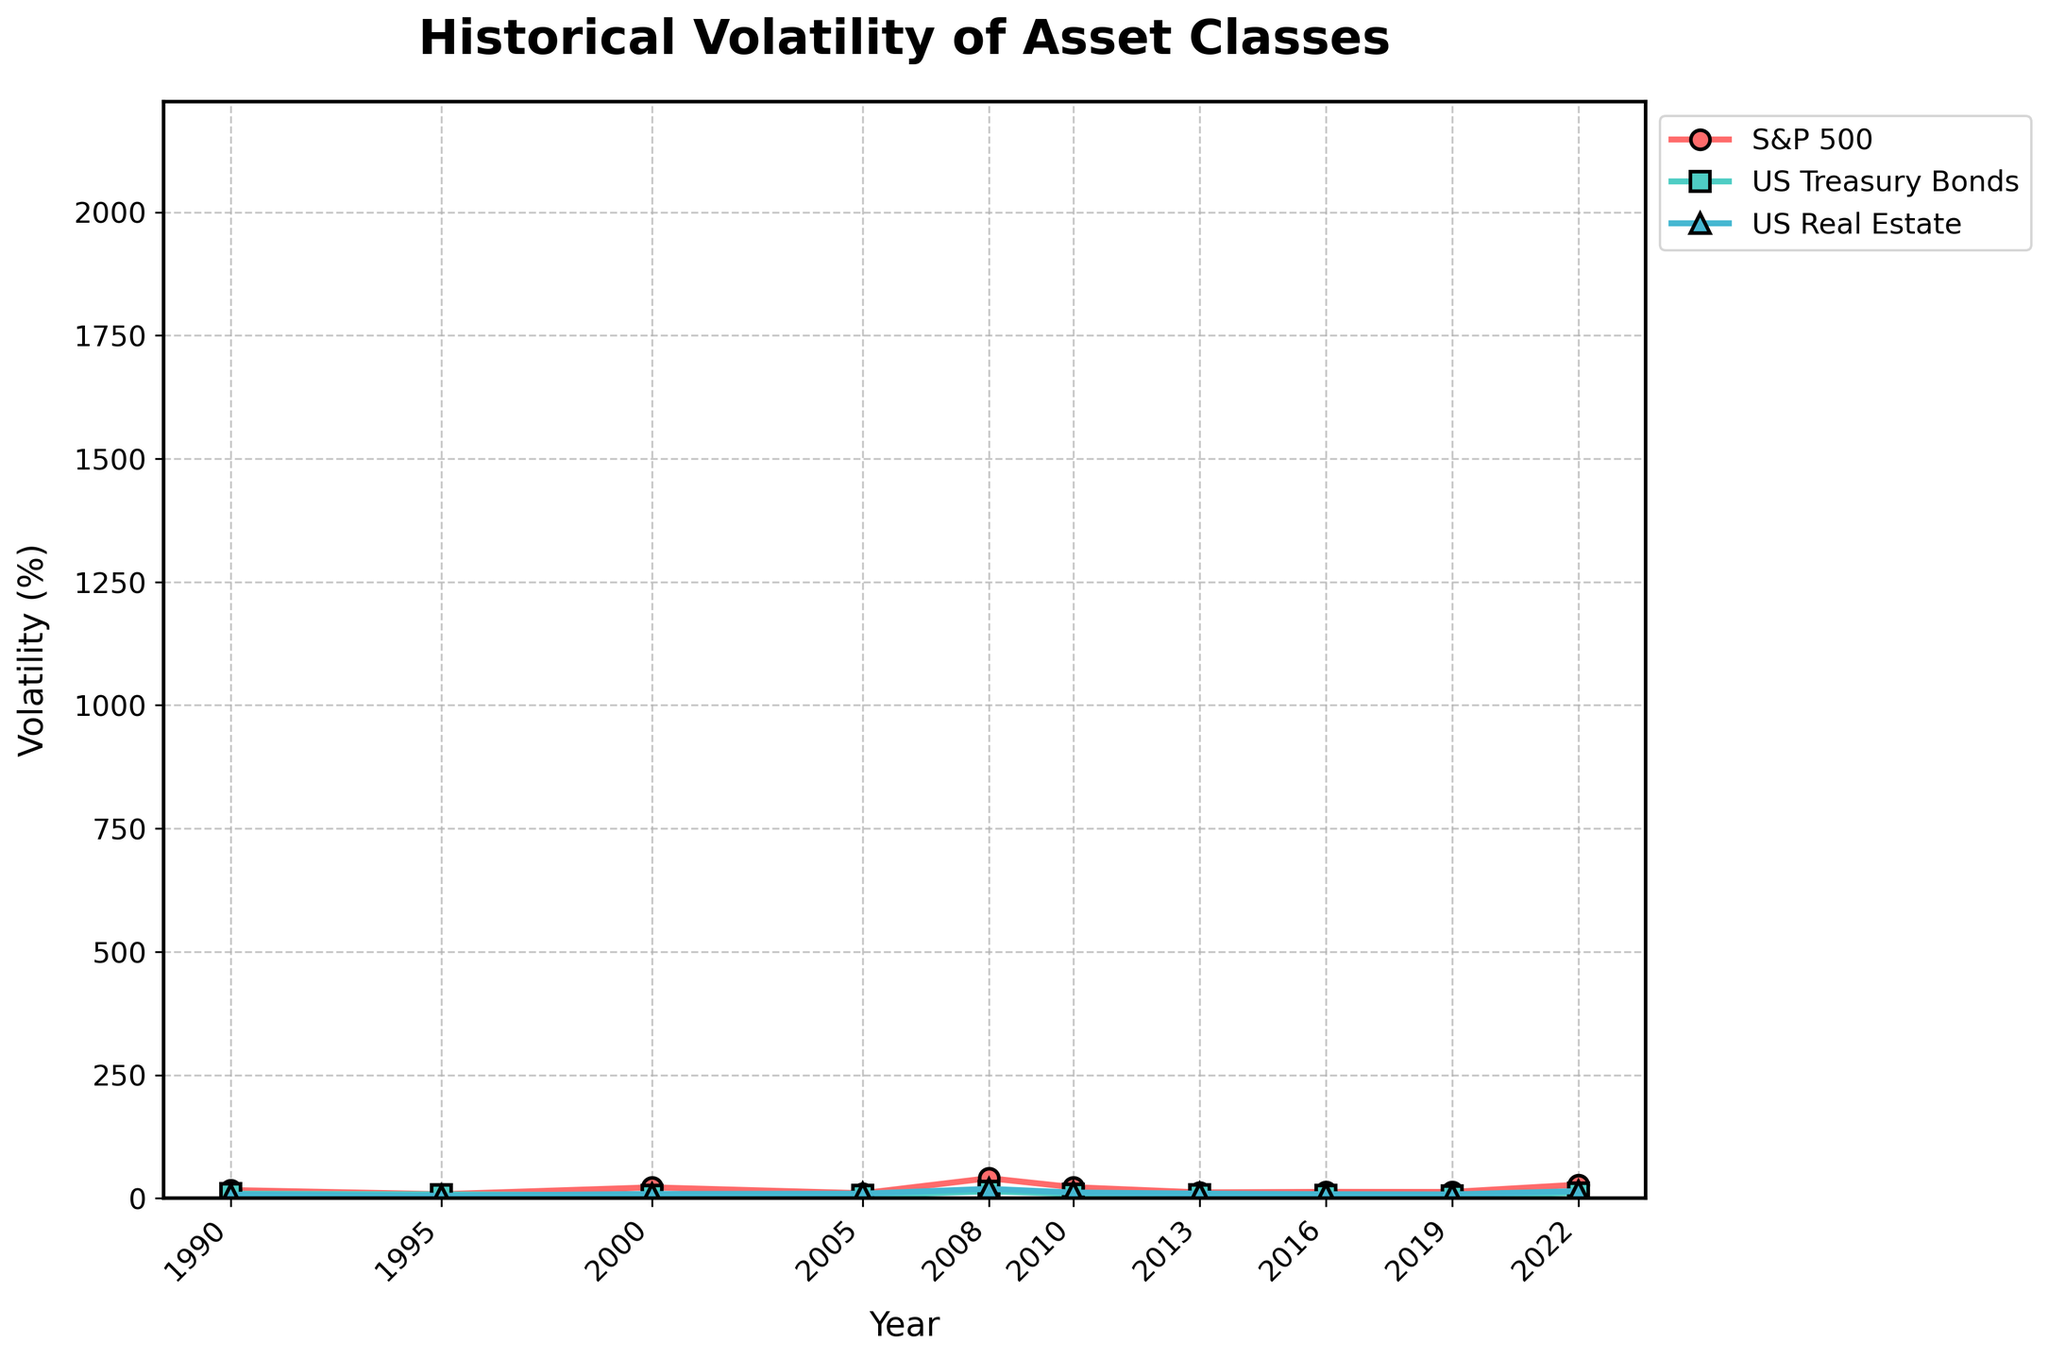Which asset class experienced the highest volatility in 2008? To find the asset class with the highest volatility in 2008, look for the highest data point in that year. For 2008, S&P 500 has a volatility of 40.79%, US Treasury Bonds have 14.03%, and US Real Estate has 19.14%.
Answer: S&P 500 What is the average volatility of US Treasury Bonds from 1990 to 2022? To find the average, sum all the volatility values for US Treasury Bonds and divide by the number of years (10). The sum is 9.32 + 7.89 + 6.41 + 5.87 + 14.03 + 8.91 + 7.81 + 6.62 + 5.18 + 11.24 = 83.28. The average is 83.28 / 10.
Answer: 8.33 Which year showed the maximum difference in volatility between S&P 500 and US Real Estate? To determine the maximum difference, calculate the absolute difference in volatilities for each year and find the maximum value. The absolute differences are: 9.26, 3.08, 13.39, 0.92, 21.65, 10.88, 2.40, 4.86, 5.06, and 13.07. The year with the highest value (21.65) is 2008.
Answer: 2008 In which year did US Real Estate have the lowest volatility? To find the year with the lowest volatility for US Real Estate, locate the smallest data point within the US Real Estate line and note the corresponding year. The values are 7.45, 5.23, 8.76, 9.32, 19.14, 11.67, 9.54, 8.21, 7.83, and 14.59. The lowest value (5.23) occurred in 1995.
Answer: 1995 Compare the volatility trends of S&P 500 and US Treasury Bonds during different market cycles (specifically the 2008 financial crisis and 2022). Observe the trends in the plot for S&P 500 and US Treasury Bonds around 2008 and 2022. During the 2008 financial crisis, S&P 500 volatility sharply increased to 40.79%, while US Treasury Bonds increased to 14.03%. In 2022, S&P 500 volatility rose to 27.66%, and US Treasury Bonds rose to 11.24%. Both asset classes saw significant increases in volatility during these periods.
Answer: S&P 500 and US Treasury Bonds both increased Which asset class had the most consistent volatility over the years? Consistency implies minimal fluctuation. Examine the trends for the three asset classes from 1990 to 2022. US Treasury Bonds show the least fluctuation in their volatility values, staying relatively stable compared to S&P 500 and US Real Estate.
Answer: US Treasury Bonds What was the volatility difference between S&P 500 and US Treasury Bonds in 2010? To find the difference, subtract the volatility of US Treasury Bonds from the S&P 500 in 2010. S&P 500 was 22.55% and US Treasury Bonds was 8.91%. The difference is 22.55 - 8.91 = 13.64.
Answer: 13.64 How did real estate volatility in 2005 compare to 1995? Compare the volatility values for US Real Estate in both years. In 1995 the volatility was 5.23%, and in 2005 it was 9.32%. Real estate volatility increased in 2005 compared to 1995.
Answer: Increased What was the percentage increase in S&P 500 volatility from 2019 to 2022? To find the percentage increase, subtract the volatility in 2019 from 2022, divide by the 2019 value, and multiply by 100. The values are 27.66% in 2022 and 12.89% in 2019. The calculation is ((27.66 - 12.89) / 12.89) * 100 = 114.68%.
Answer: 114.68 Considering the data, which asset might be deemed the safest option based on historical volatility? Analyzing the plot, US Treasury Bonds show the lowest and most consistent volatility over the years. Lower volatility generally indicates lower risk.
Answer: US Treasury Bonds 